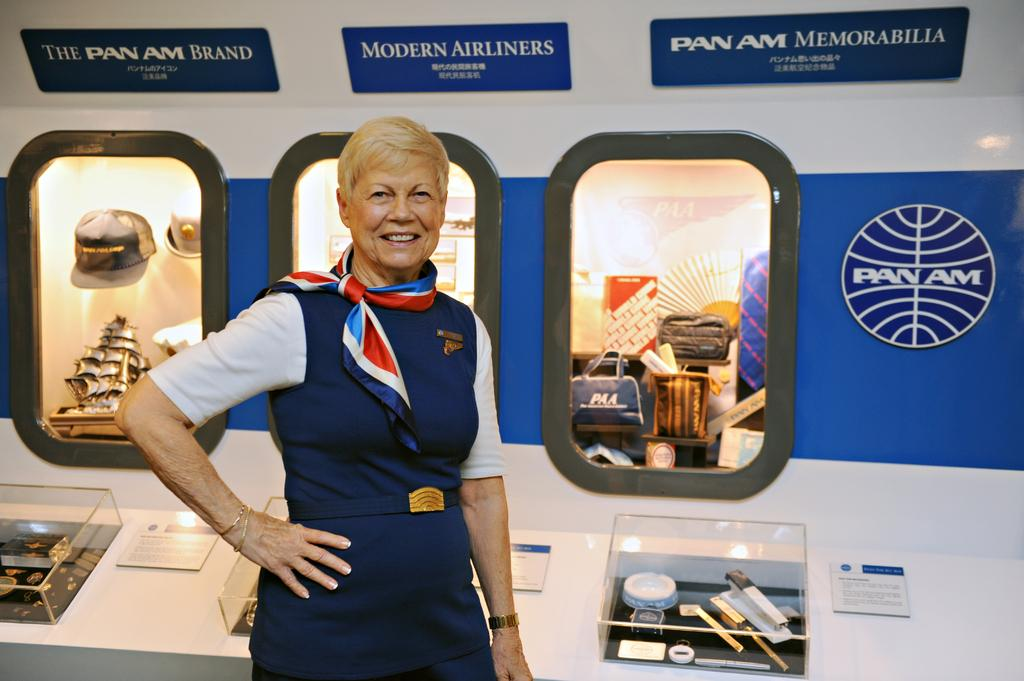Provide a one-sentence caption for the provided image. An older woman wearing Pan Am attire and standing by Pan Am memorabilia. 